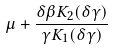Convert formula to latex. <formula><loc_0><loc_0><loc_500><loc_500>\mu + \frac { \delta \beta K _ { 2 } ( \delta \gamma ) } { \gamma K _ { 1 } ( \delta \gamma ) }</formula> 